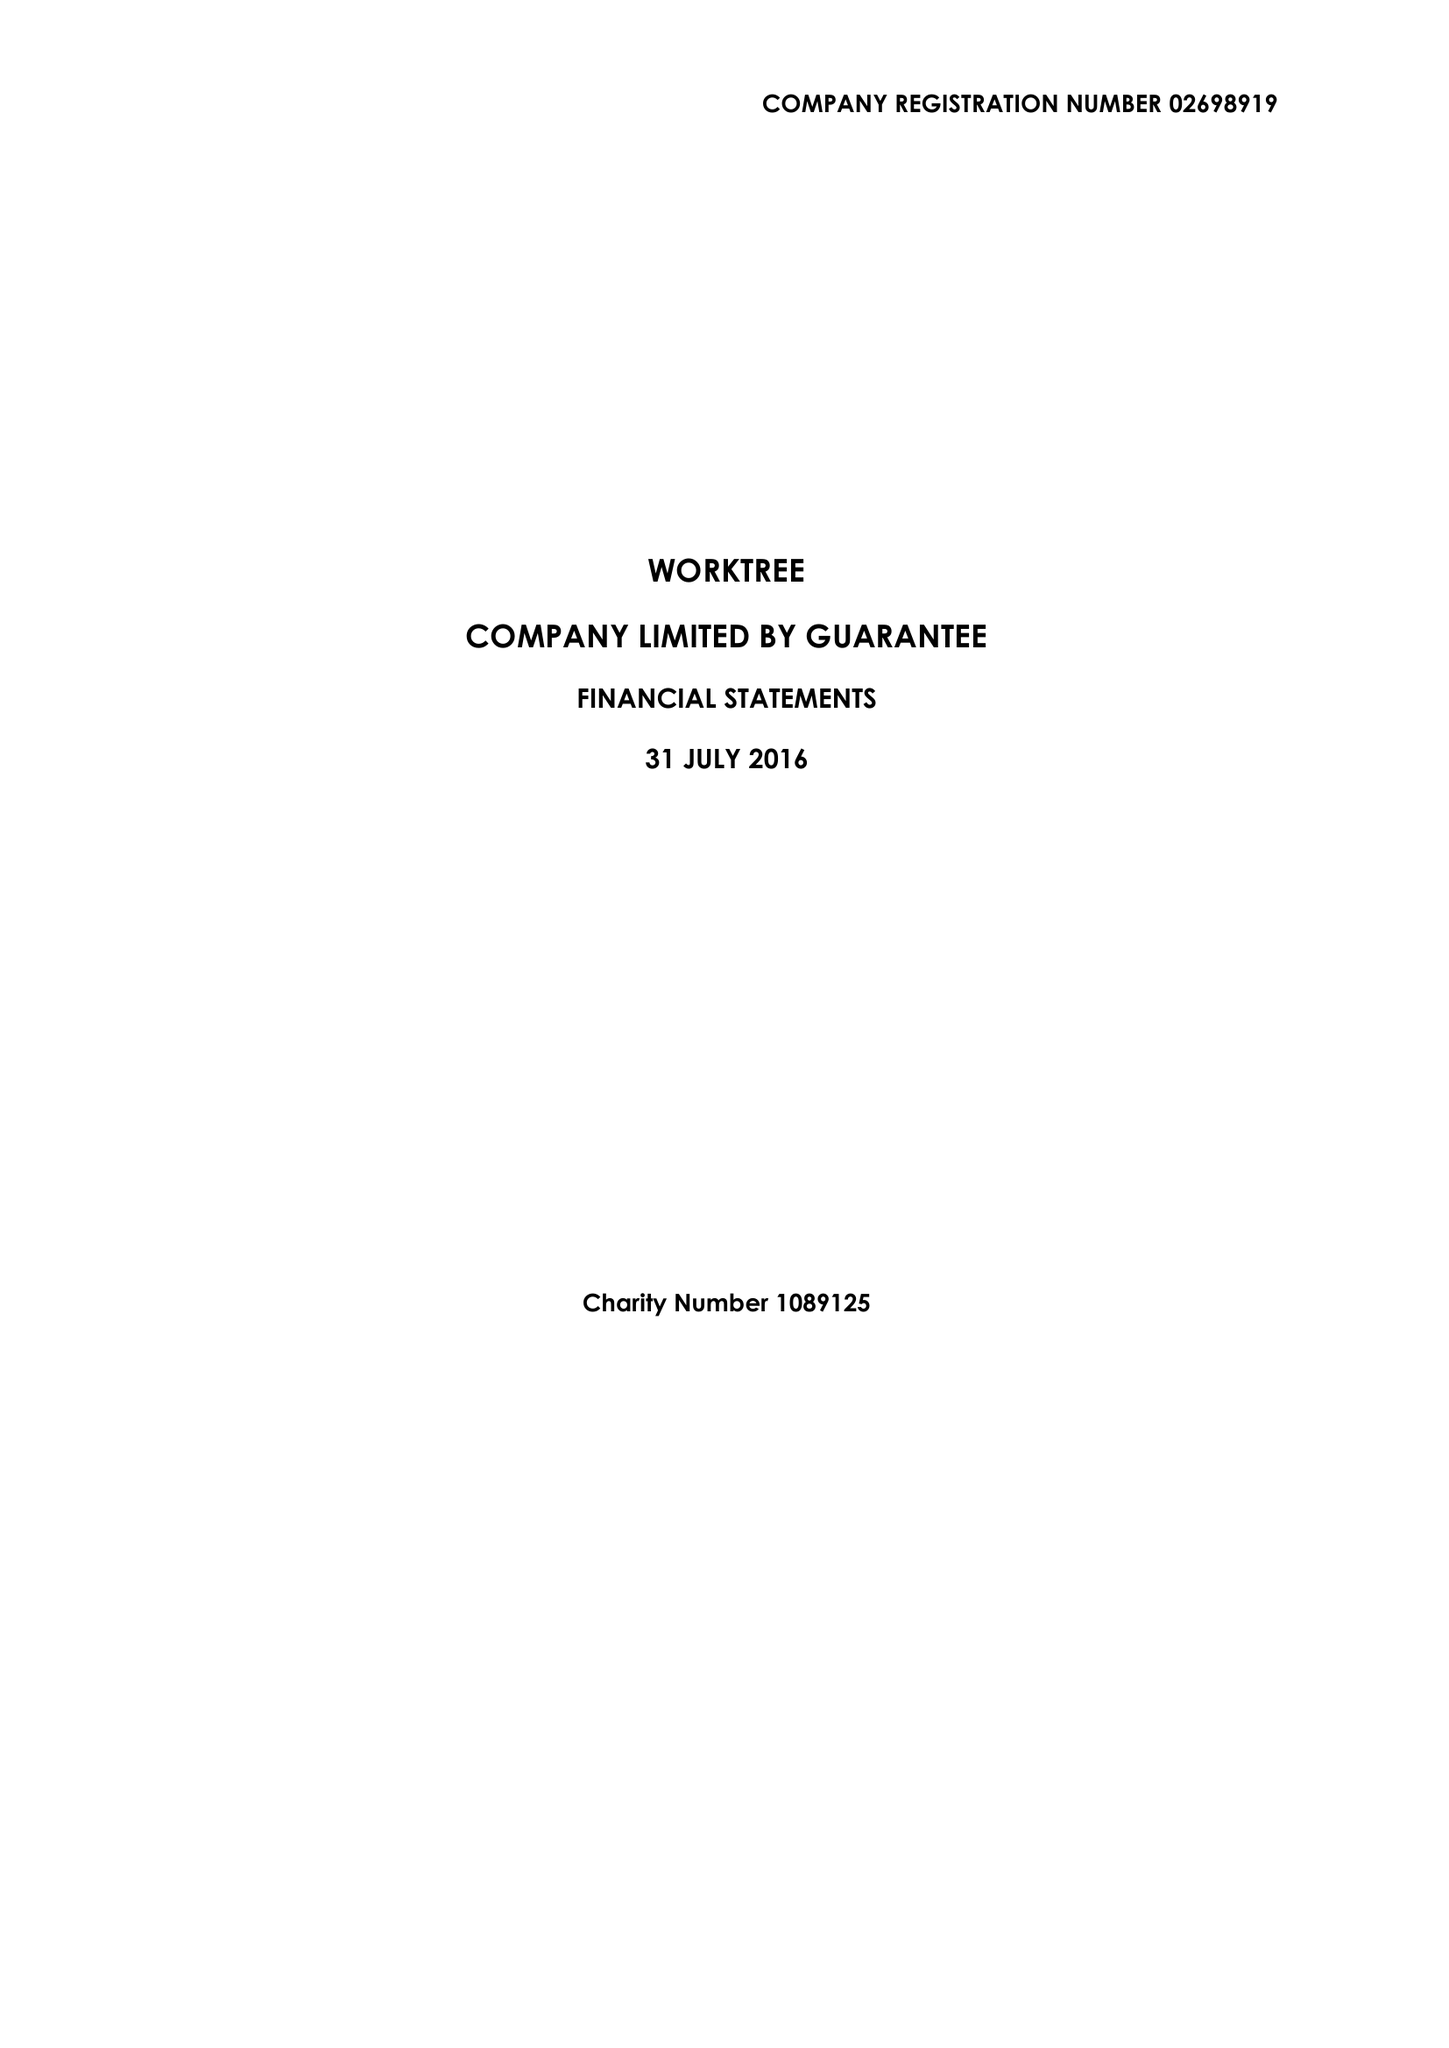What is the value for the address__postcode?
Answer the question using a single word or phrase. MK1 1LG 